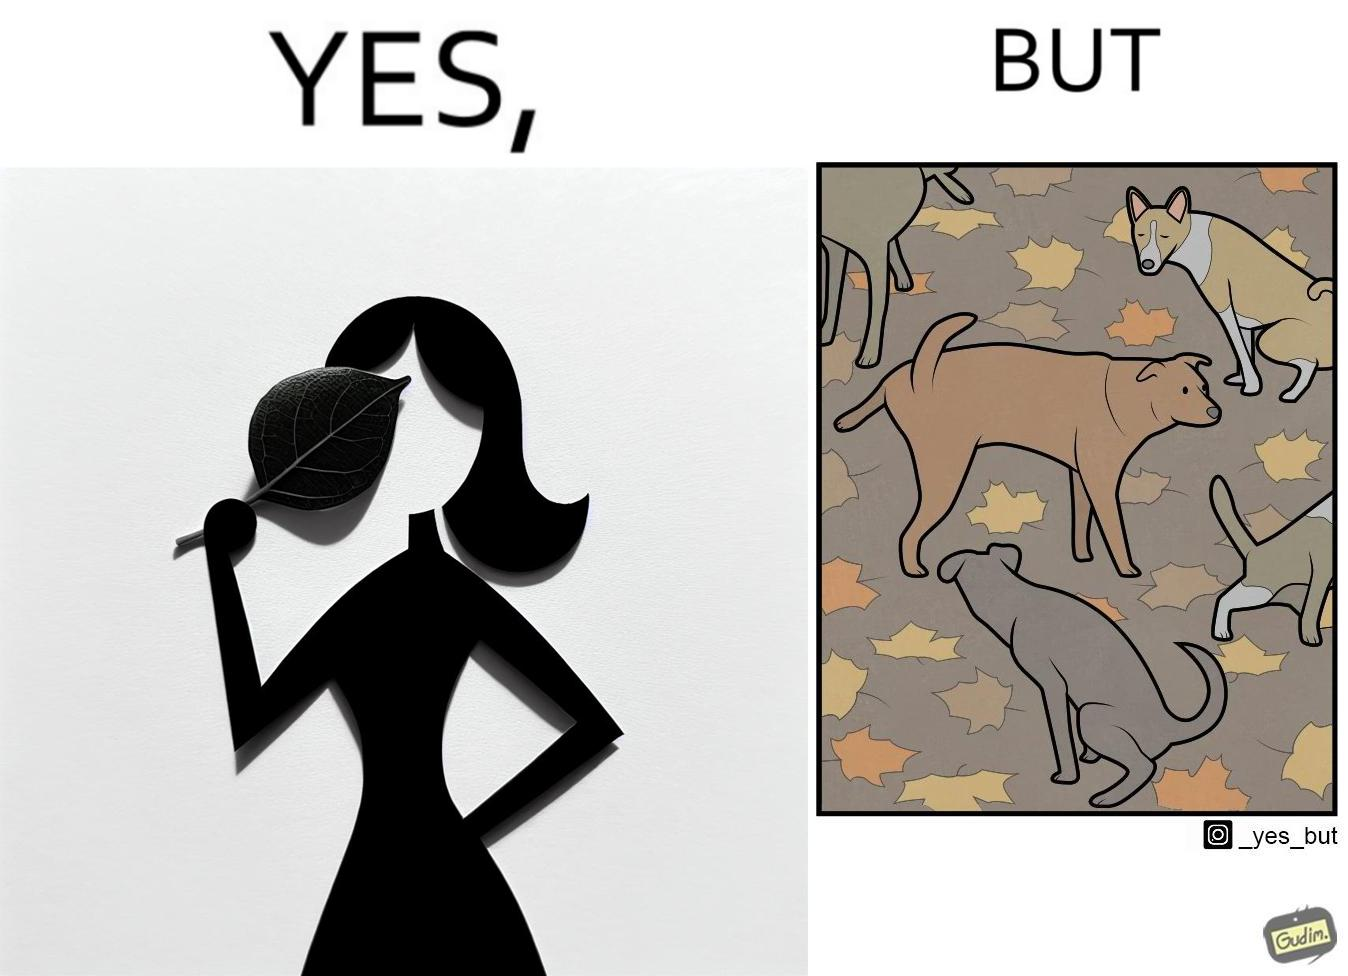What does this image depict? The images are funny since it show a woman holding a leaf over half of her face for a good photo but unknown to her is thale fact the same leaf might have been defecated or urinated upon by dogs and other wild animals 